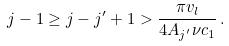<formula> <loc_0><loc_0><loc_500><loc_500>j - 1 \geq j - j ^ { \prime } + 1 > \frac { \pi v _ { l } } { 4 A _ { j ^ { \prime } } \nu c _ { 1 } } \, .</formula> 